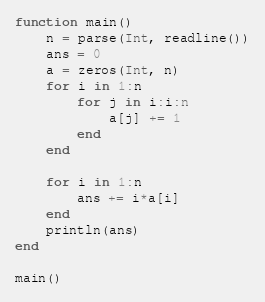Convert code to text. <code><loc_0><loc_0><loc_500><loc_500><_Julia_>function main()
    n = parse(Int, readline())
    ans = 0
    a = zeros(Int, n)
    for i in 1:n
        for j in i:i:n
            a[j] += 1
        end
    end

    for i in 1:n
        ans += i*a[i]
    end
    println(ans)
end

main()</code> 